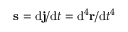<formula> <loc_0><loc_0><loc_500><loc_500>s = d j / d t = d ^ { 4 } r / d t ^ { 4 }</formula> 